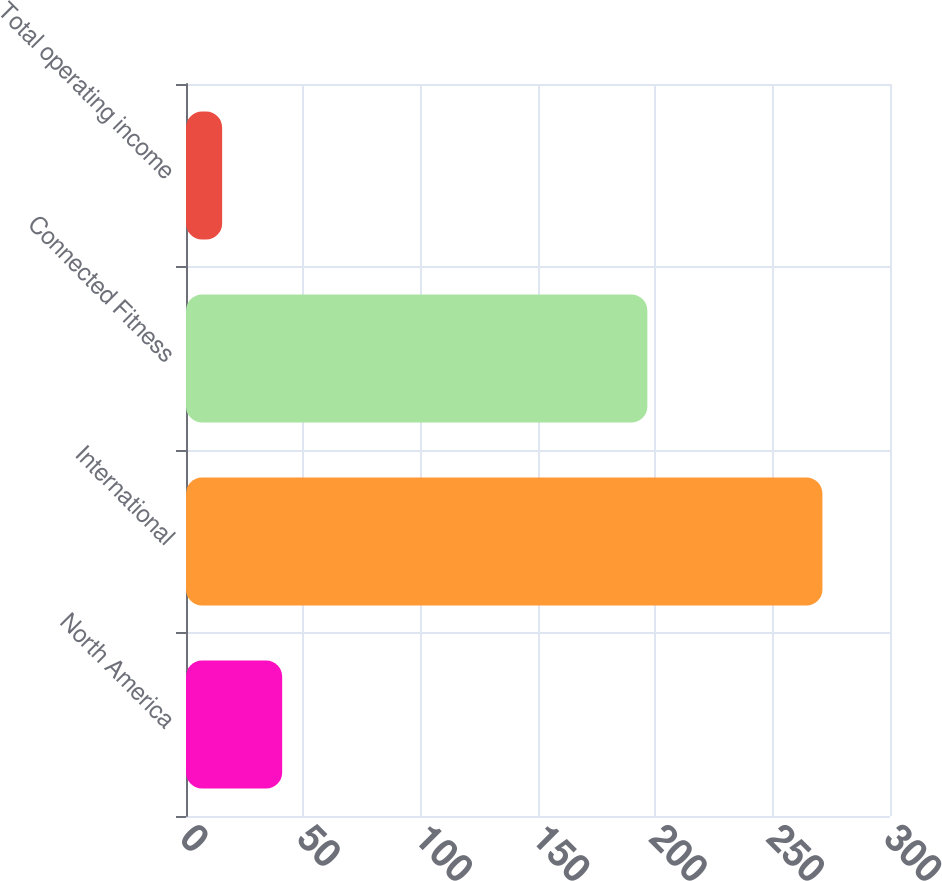Convert chart. <chart><loc_0><loc_0><loc_500><loc_500><bar_chart><fcel>North America<fcel>International<fcel>Connected Fitness<fcel>Total operating income<nl><fcel>40.98<fcel>271.2<fcel>196.6<fcel>15.4<nl></chart> 